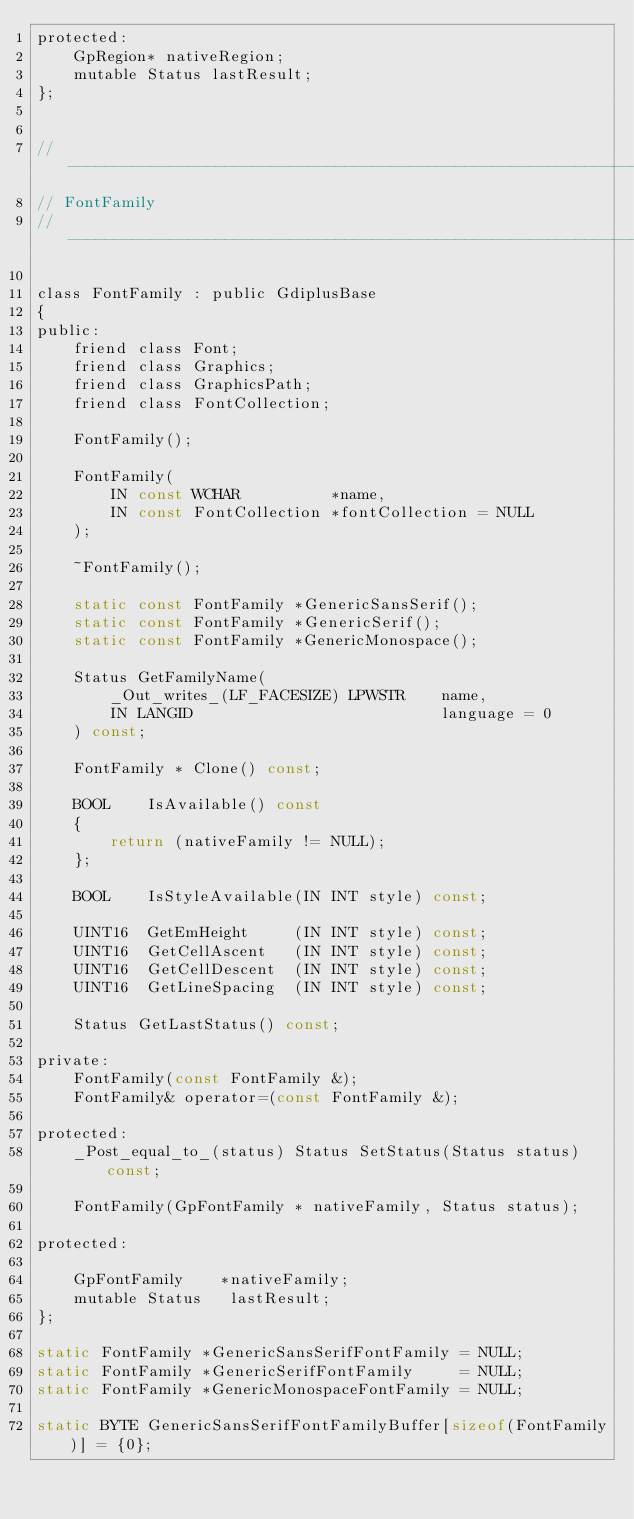Convert code to text. <code><loc_0><loc_0><loc_500><loc_500><_C_>protected:
    GpRegion* nativeRegion;
    mutable Status lastResult;
};


//--------------------------------------------------------------------------
// FontFamily
//--------------------------------------------------------------------------

class FontFamily : public GdiplusBase
{
public:
    friend class Font;
    friend class Graphics;
    friend class GraphicsPath;
    friend class FontCollection;

    FontFamily();

    FontFamily(
        IN const WCHAR          *name,
        IN const FontCollection *fontCollection = NULL
    );

    ~FontFamily();

    static const FontFamily *GenericSansSerif();
    static const FontFamily *GenericSerif();
    static const FontFamily *GenericMonospace();

    Status GetFamilyName(
        _Out_writes_(LF_FACESIZE) LPWSTR    name,
        IN LANGID                           language = 0
    ) const;

    FontFamily * Clone() const;

    BOOL    IsAvailable() const
    {
        return (nativeFamily != NULL);
    };

    BOOL    IsStyleAvailable(IN INT style) const;

    UINT16  GetEmHeight     (IN INT style) const;
    UINT16  GetCellAscent   (IN INT style) const;
    UINT16  GetCellDescent  (IN INT style) const;
    UINT16  GetLineSpacing  (IN INT style) const;
    
    Status GetLastStatus() const;

private:
    FontFamily(const FontFamily &);
    FontFamily& operator=(const FontFamily &);

protected:
    _Post_equal_to_(status) Status SetStatus(Status status) const;

    FontFamily(GpFontFamily * nativeFamily, Status status);

protected:

    GpFontFamily    *nativeFamily;
    mutable Status   lastResult;
};

static FontFamily *GenericSansSerifFontFamily = NULL;
static FontFamily *GenericSerifFontFamily     = NULL;
static FontFamily *GenericMonospaceFontFamily = NULL;

static BYTE GenericSansSerifFontFamilyBuffer[sizeof(FontFamily)] = {0};</code> 